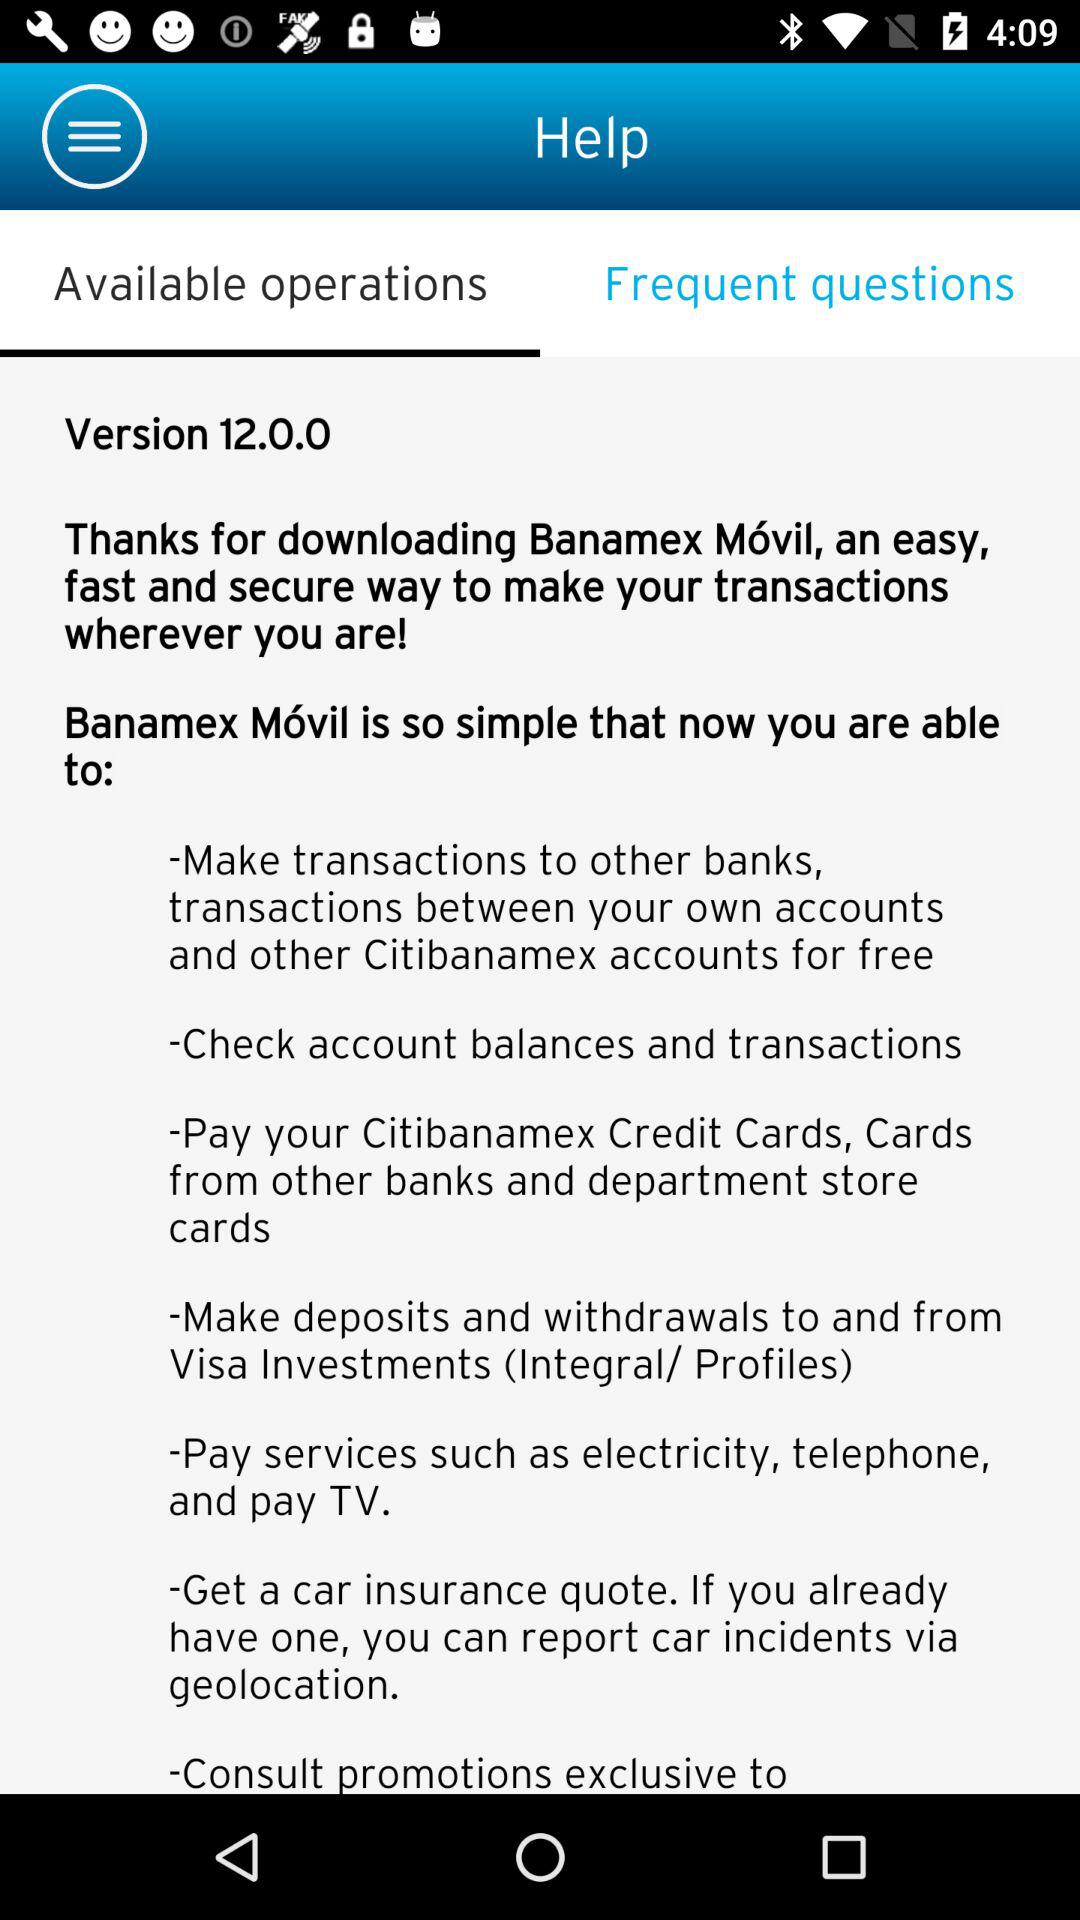What is the version? The version is 12.0.0. 